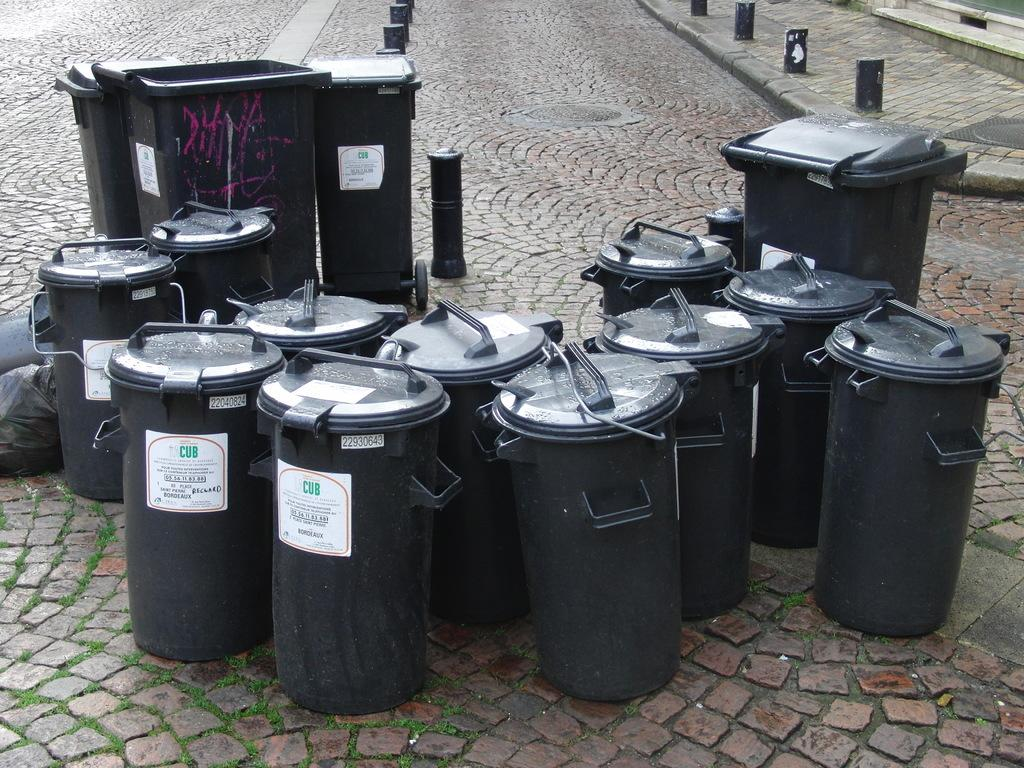<image>
Relay a brief, clear account of the picture shown. Smaller and Larger Black Garbage bins gathered on a street. 